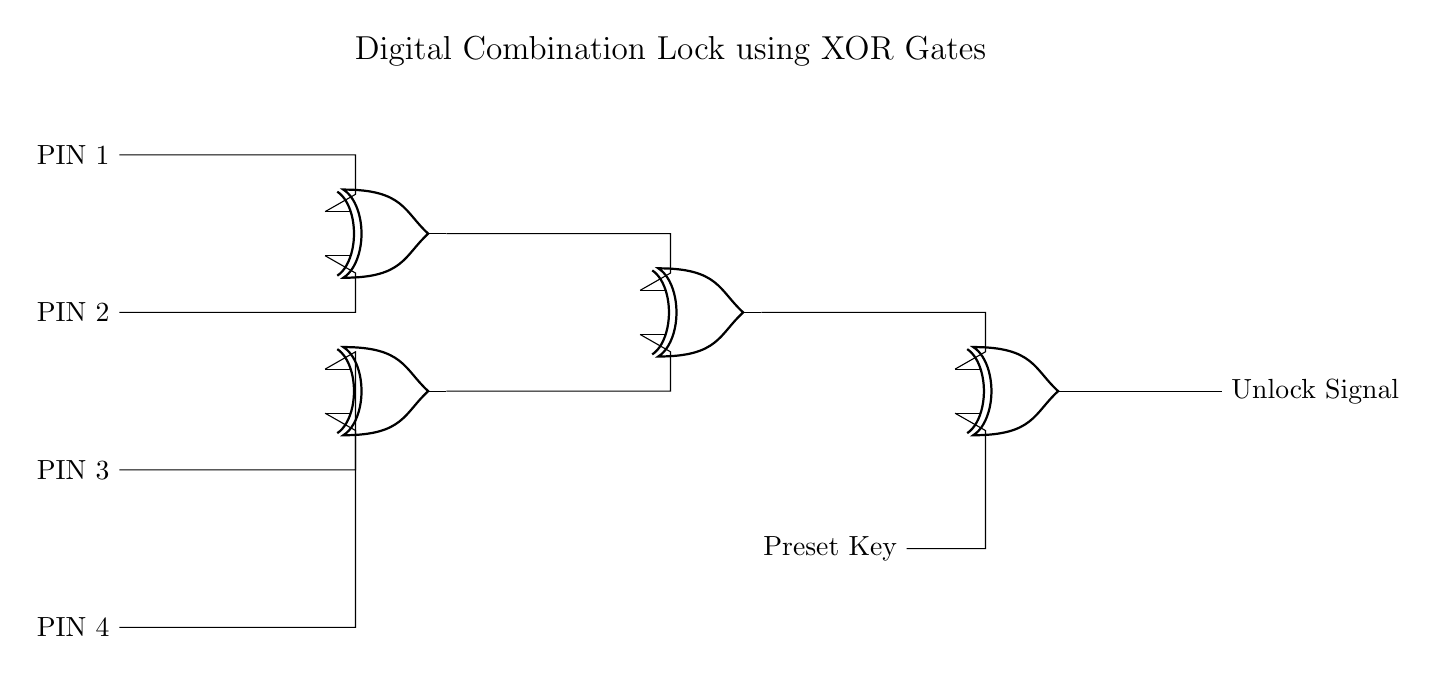What do the inputs represent? The inputs represent four different PINs labeled as PIN 1, PIN 2, PIN 3, and PIN 4. Each PIN serves as a binary input to the circuit.
Answer: Four PINs How many XOR gates are used in the circuit? The circuit contains four XOR gates that handle the combination logic to produce the unlock signal from the specified input PINs.
Answer: Four What does the output signify? The output signifies the unlock signal, which indicates whether the correct combination has been provided through the input PINs.
Answer: Unlock signal What is the function of the preset key? The preset key is added as a secondary input to one of the XOR gates to modify the output based on a specific desired combination, enhancing security.
Answer: Modify output What happens when all PINs are equal? When all PINs are equal (0 or 1), the output will be low, meaning the unlock signal will not be triggered; this is due to the properties of XOR gates, which output high only when inputs differ.
Answer: Output is low Why are XOR gates used in this circuit? XOR gates are used because they provide a unique output when the inputs differ, which is essential for generating an unlock signal only when the correct combination of alphanumeric inputs is given.
Answer: Unique output What is the role of the second input in the final XOR gate? The second input in the final XOR gate is the preset key, which augments the logic of the prior processed PIN inputs to determine the final unlock signal output based on a specific combination requirement.
Answer: Augments logic 